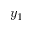Convert formula to latex. <formula><loc_0><loc_0><loc_500><loc_500>y _ { 1 }</formula> 